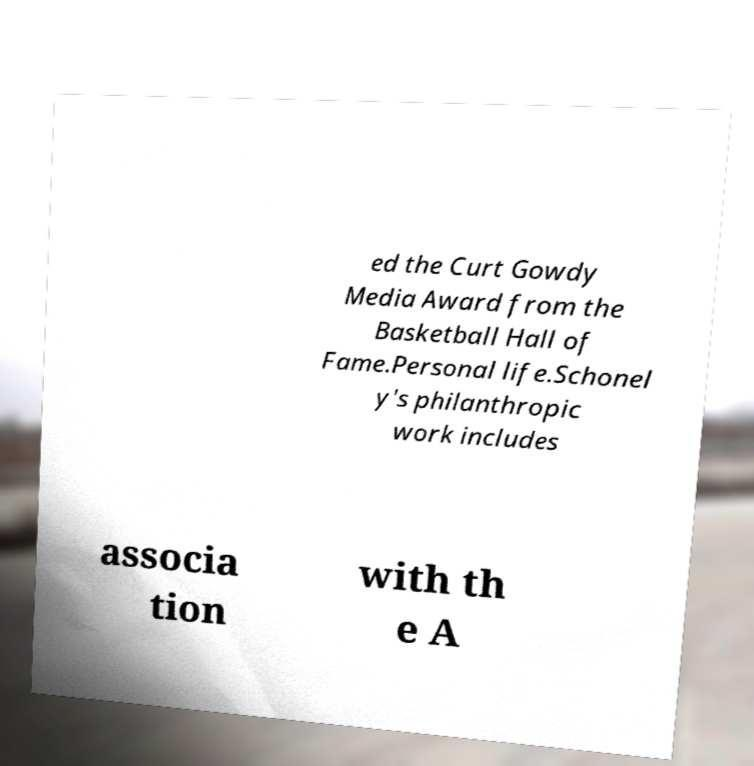There's text embedded in this image that I need extracted. Can you transcribe it verbatim? ed the Curt Gowdy Media Award from the Basketball Hall of Fame.Personal life.Schonel y's philanthropic work includes associa tion with th e A 